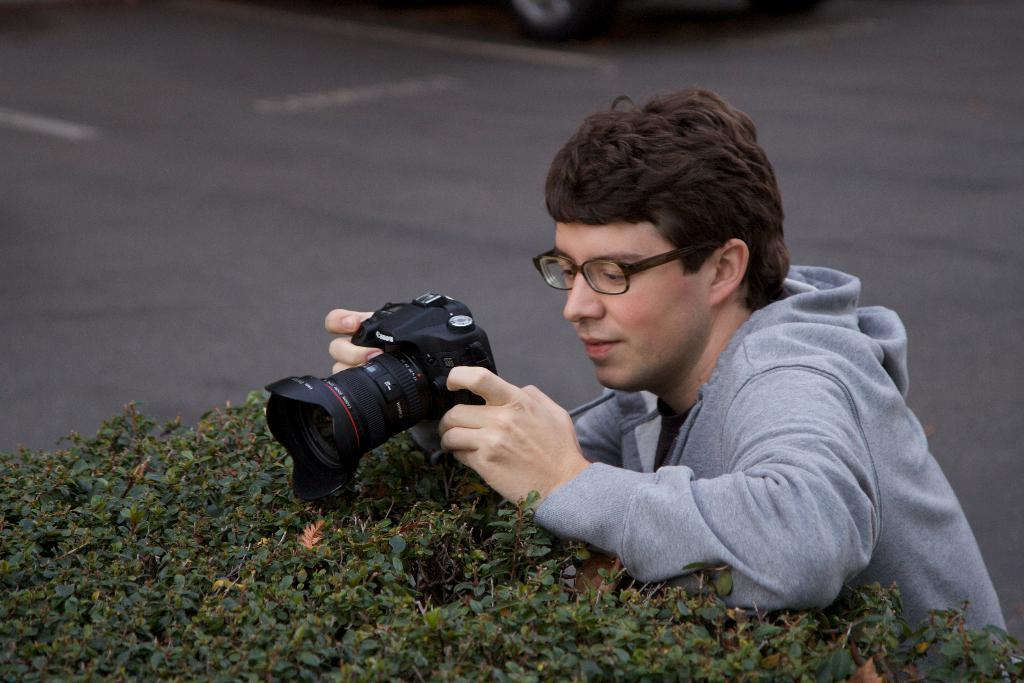What is the main subject of the picture? The main subject of the picture is a man. What is the man wearing in the image? The man is wearing spectacles in the image. What is the man holding in the picture? The man is holding a camera in the image. What is the man doing with the camera? The man is clicking a picture with the camera. What can be seen in the background of the image? There is a road in the background of the image. What type of vegetation is visible in the image? There are plants visible in the image. What type of note is the man holding in the image? There is no note present in the image; the man is holding a camera. Can you see a kitty playing with the plants in the image? There is no kitty present in the image; only the man, his camera, the road, and the plants can be seen. 